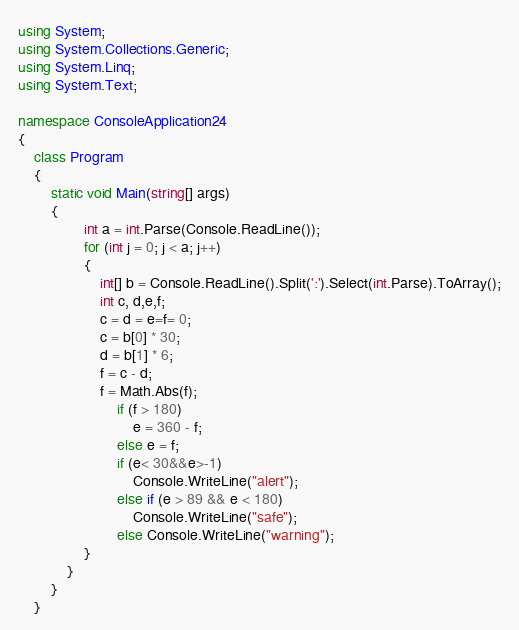Convert code to text. <code><loc_0><loc_0><loc_500><loc_500><_C#_>using System;
using System.Collections.Generic;
using System.Linq;
using System.Text;

namespace ConsoleApplication24
{
    class Program
    {
        static void Main(string[] args)
        {
                int a = int.Parse(Console.ReadLine());
                for (int j = 0; j < a; j++)
                {
                    int[] b = Console.ReadLine().Split(':').Select(int.Parse).ToArray();
                    int c, d,e,f;
                    c = d = e=f= 0;
                    c = b[0] * 30;
                    d = b[1] * 6;
                    f = c - d;
                    f = Math.Abs(f);
                        if (f > 180)
                            e = 360 - f;
                        else e = f;
                        if (e< 30&&e>-1)
                            Console.WriteLine("alert");
                        else if (e > 89 && e < 180)
                            Console.WriteLine("safe");
                        else Console.WriteLine("warning");
                }
            }
        }
    }</code> 